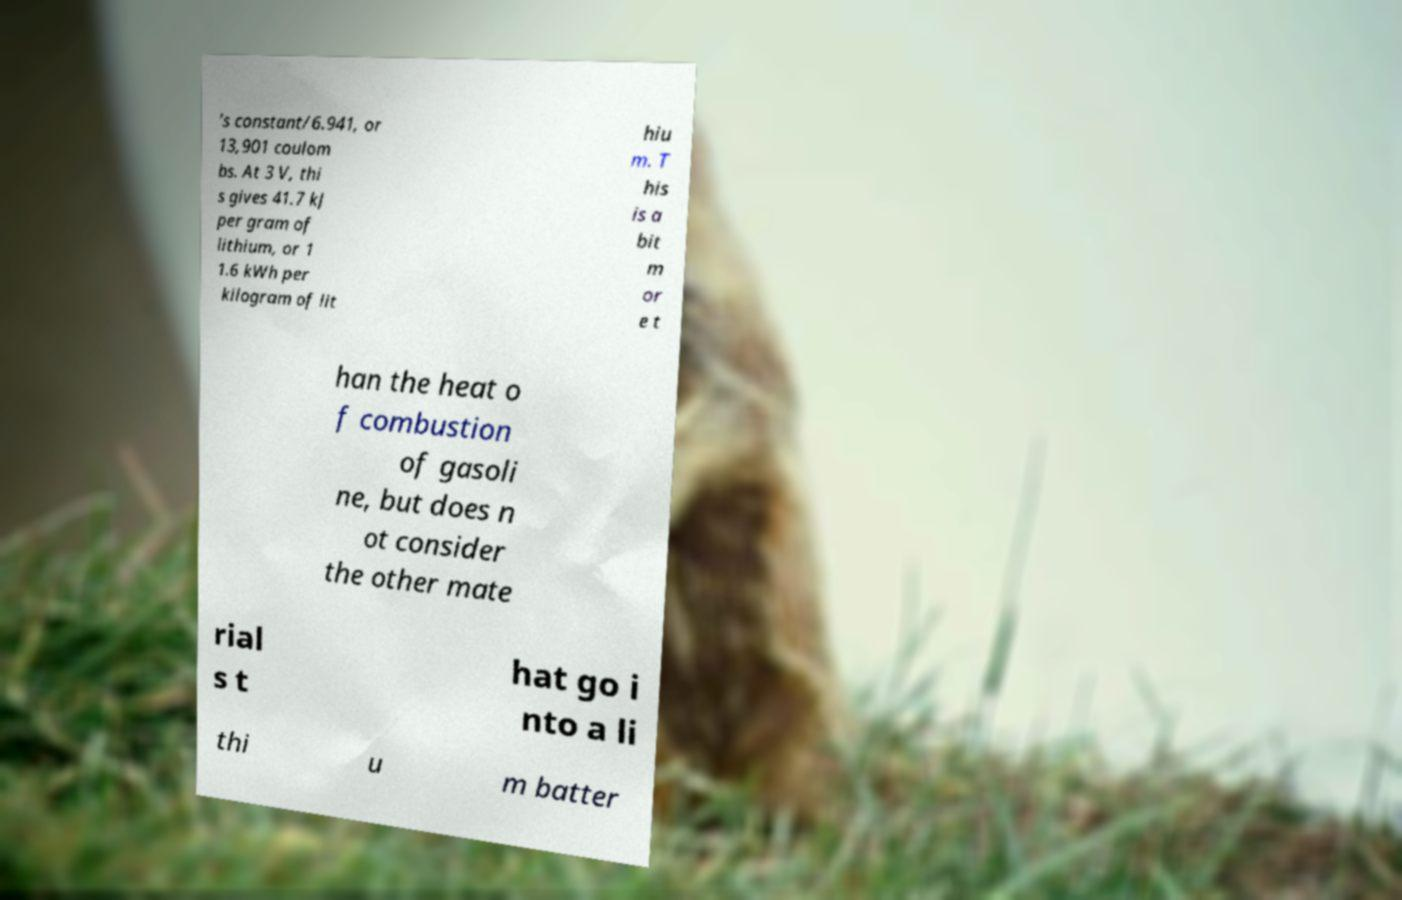Can you accurately transcribe the text from the provided image for me? 's constant/6.941, or 13,901 coulom bs. At 3 V, thi s gives 41.7 kJ per gram of lithium, or 1 1.6 kWh per kilogram of lit hiu m. T his is a bit m or e t han the heat o f combustion of gasoli ne, but does n ot consider the other mate rial s t hat go i nto a li thi u m batter 